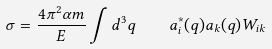Convert formula to latex. <formula><loc_0><loc_0><loc_500><loc_500>\sigma = \frac { 4 \pi ^ { 2 } \alpha m } { E } \int d ^ { 3 } q \quad a ^ { * } _ { i } ( { q } ) a _ { k } ( { q } ) W _ { i k }</formula> 